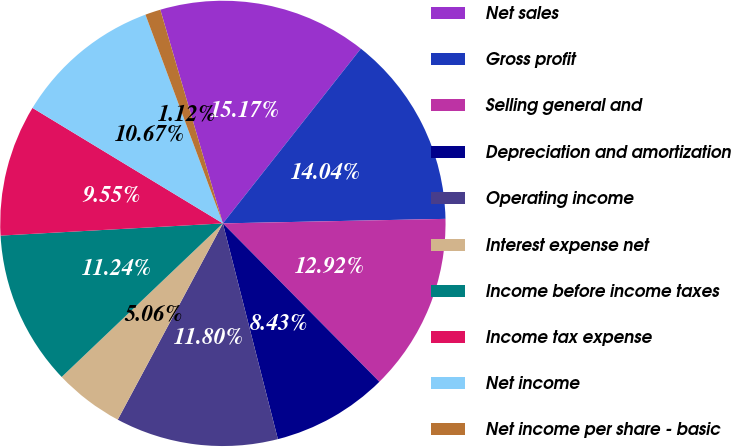<chart> <loc_0><loc_0><loc_500><loc_500><pie_chart><fcel>Net sales<fcel>Gross profit<fcel>Selling general and<fcel>Depreciation and amortization<fcel>Operating income<fcel>Interest expense net<fcel>Income before income taxes<fcel>Income tax expense<fcel>Net income<fcel>Net income per share - basic<nl><fcel>15.17%<fcel>14.04%<fcel>12.92%<fcel>8.43%<fcel>11.8%<fcel>5.06%<fcel>11.24%<fcel>9.55%<fcel>10.67%<fcel>1.12%<nl></chart> 